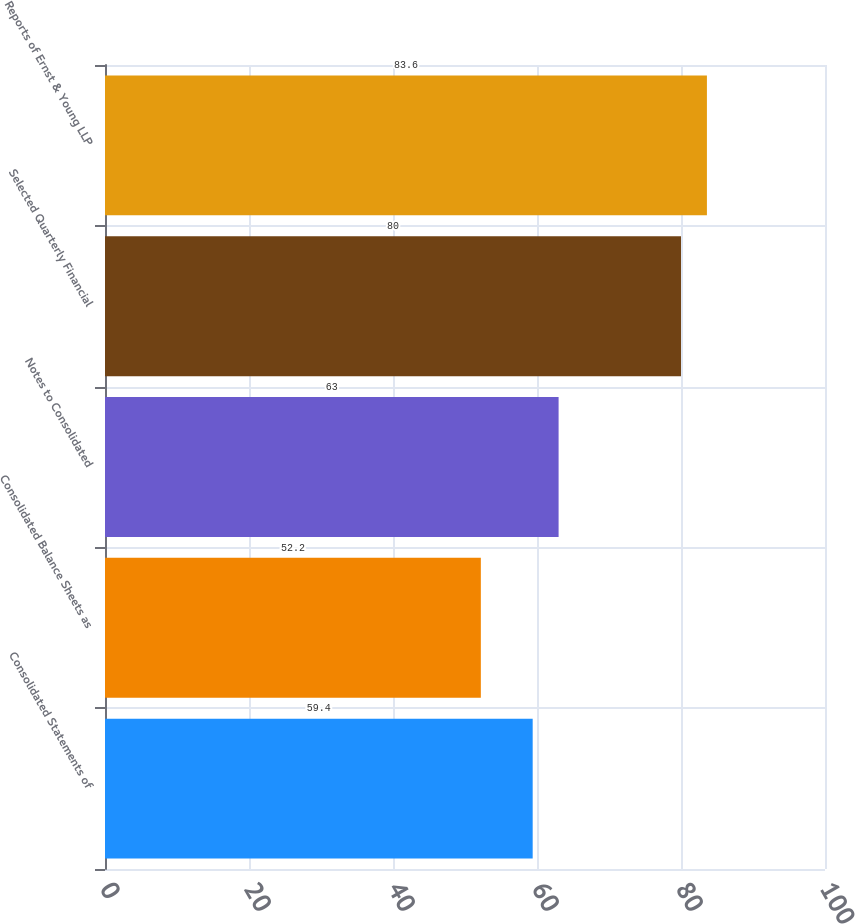Convert chart. <chart><loc_0><loc_0><loc_500><loc_500><bar_chart><fcel>Consolidated Statements of<fcel>Consolidated Balance Sheets as<fcel>Notes to Consolidated<fcel>Selected Quarterly Financial<fcel>Reports of Ernst & Young LLP<nl><fcel>59.4<fcel>52.2<fcel>63<fcel>80<fcel>83.6<nl></chart> 